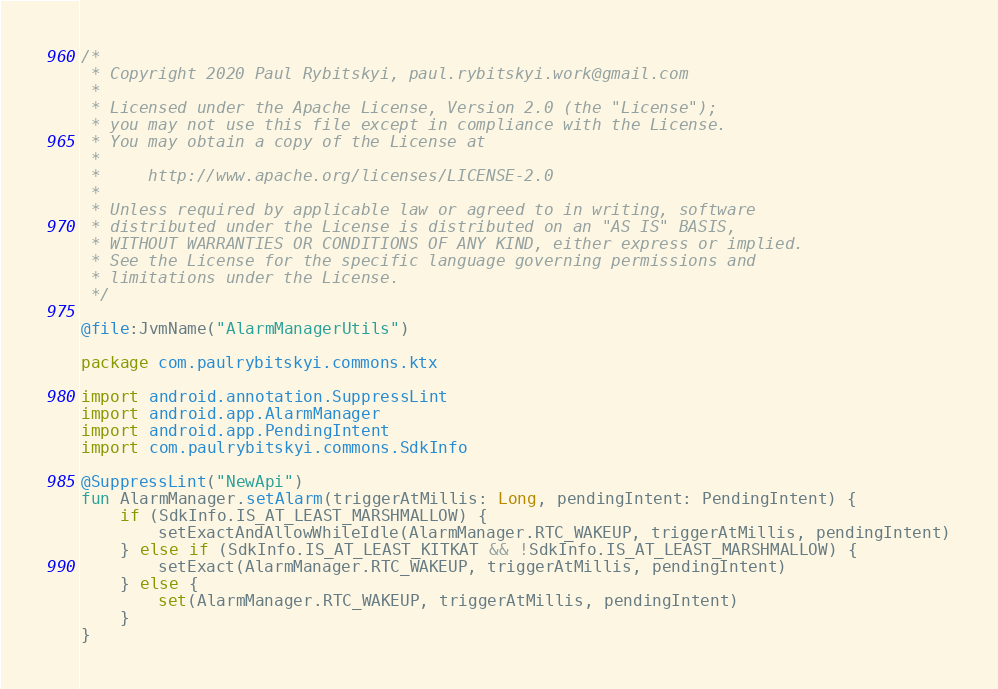<code> <loc_0><loc_0><loc_500><loc_500><_Kotlin_>/*
 * Copyright 2020 Paul Rybitskyi, paul.rybitskyi.work@gmail.com
 *
 * Licensed under the Apache License, Version 2.0 (the "License");
 * you may not use this file except in compliance with the License.
 * You may obtain a copy of the License at
 *
 *     http://www.apache.org/licenses/LICENSE-2.0
 *
 * Unless required by applicable law or agreed to in writing, software
 * distributed under the License is distributed on an "AS IS" BASIS,
 * WITHOUT WARRANTIES OR CONDITIONS OF ANY KIND, either express or implied.
 * See the License for the specific language governing permissions and
 * limitations under the License.
 */

@file:JvmName("AlarmManagerUtils")

package com.paulrybitskyi.commons.ktx

import android.annotation.SuppressLint
import android.app.AlarmManager
import android.app.PendingIntent
import com.paulrybitskyi.commons.SdkInfo

@SuppressLint("NewApi")
fun AlarmManager.setAlarm(triggerAtMillis: Long, pendingIntent: PendingIntent) {
    if (SdkInfo.IS_AT_LEAST_MARSHMALLOW) {
        setExactAndAllowWhileIdle(AlarmManager.RTC_WAKEUP, triggerAtMillis, pendingIntent)
    } else if (SdkInfo.IS_AT_LEAST_KITKAT && !SdkInfo.IS_AT_LEAST_MARSHMALLOW) {
        setExact(AlarmManager.RTC_WAKEUP, triggerAtMillis, pendingIntent)
    } else {
        set(AlarmManager.RTC_WAKEUP, triggerAtMillis, pendingIntent)
    }
}
</code> 